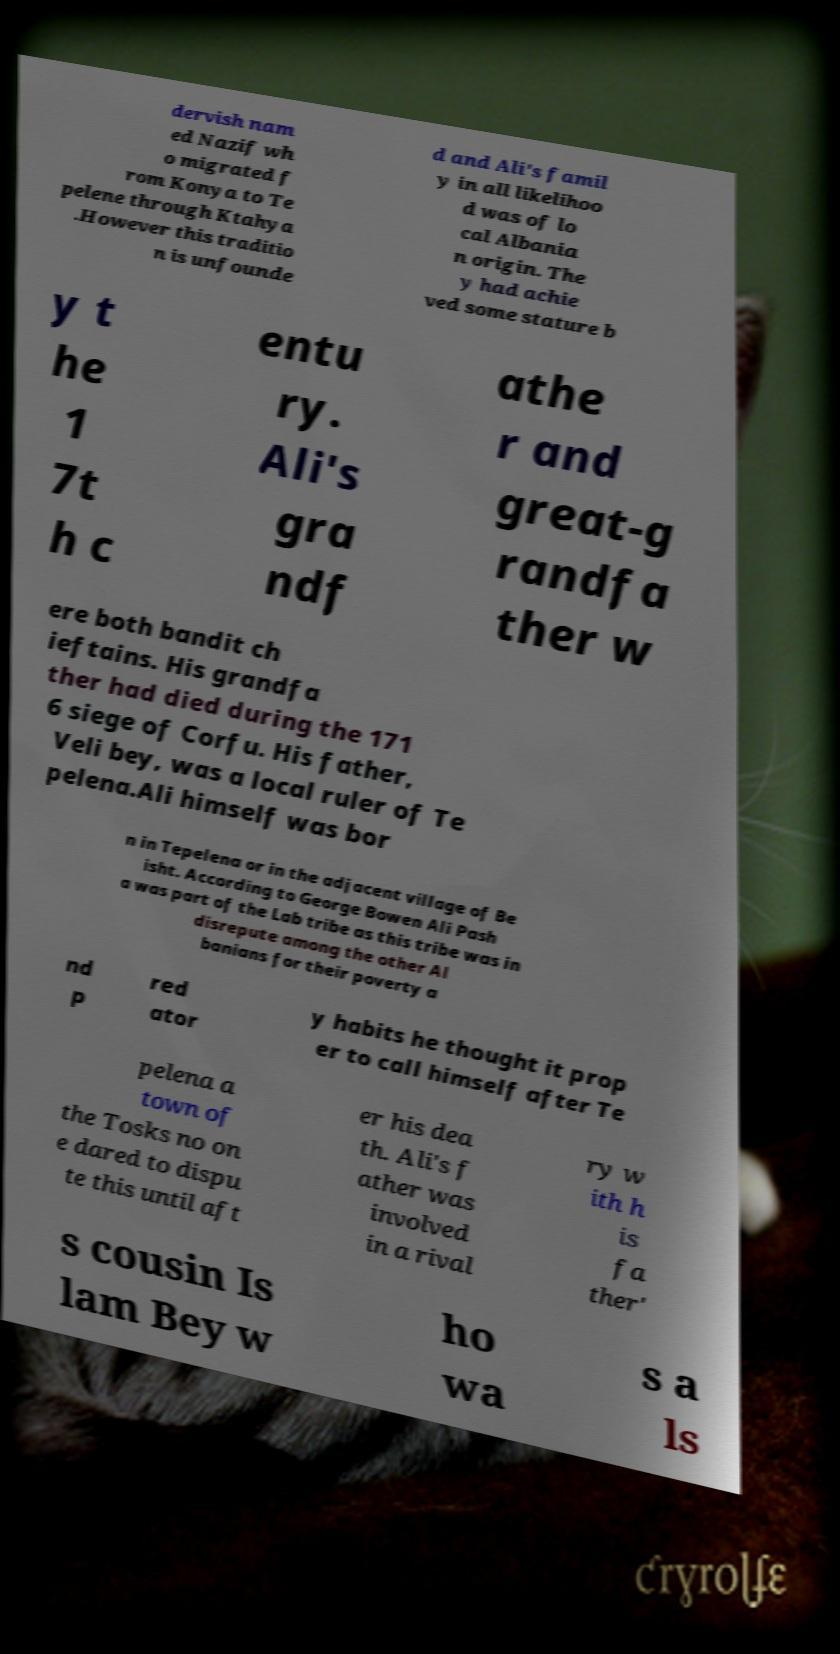Could you extract and type out the text from this image? dervish nam ed Nazif wh o migrated f rom Konya to Te pelene through Ktahya .However this traditio n is unfounde d and Ali's famil y in all likelihoo d was of lo cal Albania n origin. The y had achie ved some stature b y t he 1 7t h c entu ry. Ali's gra ndf athe r and great-g randfa ther w ere both bandit ch ieftains. His grandfa ther had died during the 171 6 siege of Corfu. His father, Veli bey, was a local ruler of Te pelena.Ali himself was bor n in Tepelena or in the adjacent village of Be isht. According to George Bowen Ali Pash a was part of the Lab tribe as this tribe was in disrepute among the other Al banians for their poverty a nd p red ator y habits he thought it prop er to call himself after Te pelena a town of the Tosks no on e dared to dispu te this until aft er his dea th. Ali's f ather was involved in a rival ry w ith h is fa ther' s cousin Is lam Bey w ho wa s a ls 